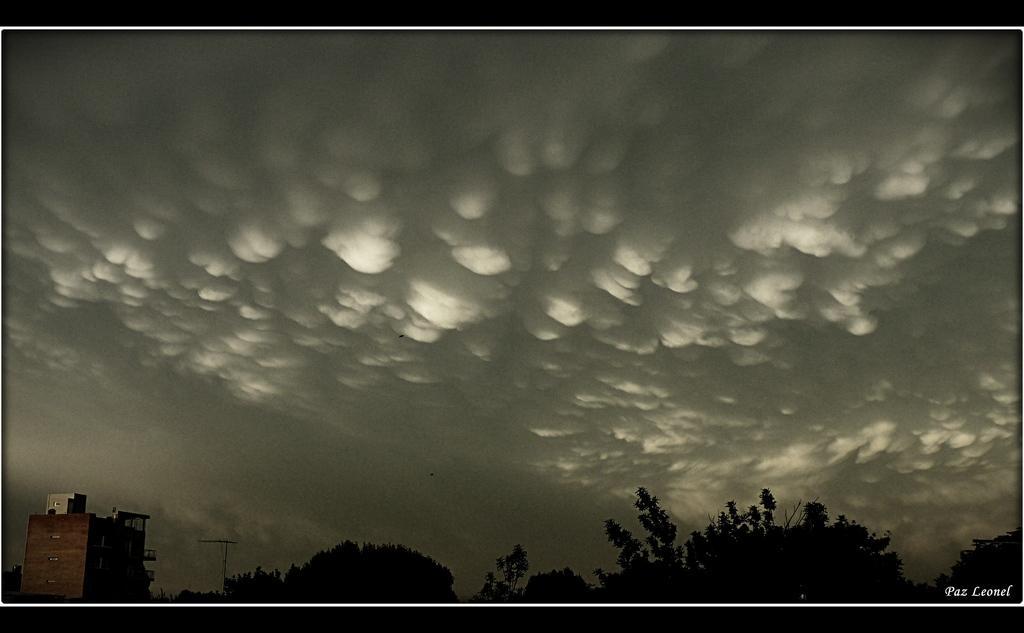How would you summarize this image in a sentence or two? In this image I can see many trees. To the left I can see the building. In the back there are clouds and the sky. 